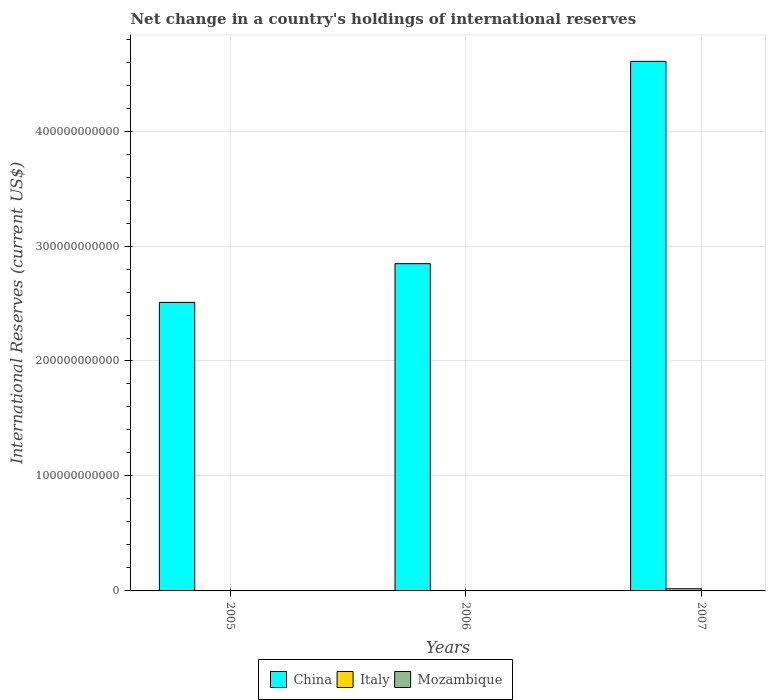Are the number of bars on each tick of the X-axis equal?
Ensure brevity in your answer.  No. How many bars are there on the 3rd tick from the left?
Provide a succinct answer. 3. How many bars are there on the 3rd tick from the right?
Offer a very short reply. 1. What is the label of the 2nd group of bars from the left?
Your answer should be very brief. 2006. In how many cases, is the number of bars for a given year not equal to the number of legend labels?
Offer a terse response. 2. Across all years, what is the maximum international reserves in Italy?
Provide a succinct answer. 1.89e+09. Across all years, what is the minimum international reserves in China?
Your response must be concise. 2.51e+11. In which year was the international reserves in Mozambique maximum?
Provide a short and direct response. 2007. What is the total international reserves in Italy in the graph?
Provide a short and direct response. 1.89e+09. What is the difference between the international reserves in China in 2005 and that in 2006?
Keep it short and to the point. -3.37e+1. What is the difference between the international reserves in Italy in 2007 and the international reserves in China in 2006?
Provide a succinct answer. -2.83e+11. What is the average international reserves in China per year?
Your answer should be very brief. 3.32e+11. In the year 2007, what is the difference between the international reserves in Italy and international reserves in Mozambique?
Your answer should be very brief. 1.76e+09. In how many years, is the international reserves in Italy greater than 60000000000 US$?
Make the answer very short. 0. What is the ratio of the international reserves in China in 2005 to that in 2007?
Provide a short and direct response. 0.54. What is the difference between the highest and the second highest international reserves in China?
Offer a very short reply. 1.76e+11. What is the difference between the highest and the lowest international reserves in Mozambique?
Make the answer very short. 1.37e+08. In how many years, is the international reserves in Mozambique greater than the average international reserves in Mozambique taken over all years?
Provide a short and direct response. 1. Is the sum of the international reserves in China in 2005 and 2006 greater than the maximum international reserves in Italy across all years?
Offer a terse response. Yes. How many bars are there?
Your answer should be compact. 5. What is the difference between two consecutive major ticks on the Y-axis?
Offer a very short reply. 1.00e+11. Does the graph contain any zero values?
Your response must be concise. Yes. How many legend labels are there?
Offer a very short reply. 3. How are the legend labels stacked?
Your answer should be very brief. Horizontal. What is the title of the graph?
Your answer should be compact. Net change in a country's holdings of international reserves. What is the label or title of the X-axis?
Ensure brevity in your answer.  Years. What is the label or title of the Y-axis?
Ensure brevity in your answer.  International Reserves (current US$). What is the International Reserves (current US$) in China in 2005?
Give a very brief answer. 2.51e+11. What is the International Reserves (current US$) in China in 2006?
Offer a very short reply. 2.85e+11. What is the International Reserves (current US$) of China in 2007?
Your answer should be compact. 4.61e+11. What is the International Reserves (current US$) of Italy in 2007?
Your answer should be very brief. 1.89e+09. What is the International Reserves (current US$) of Mozambique in 2007?
Ensure brevity in your answer.  1.37e+08. Across all years, what is the maximum International Reserves (current US$) of China?
Your answer should be compact. 4.61e+11. Across all years, what is the maximum International Reserves (current US$) in Italy?
Your answer should be very brief. 1.89e+09. Across all years, what is the maximum International Reserves (current US$) in Mozambique?
Offer a terse response. 1.37e+08. Across all years, what is the minimum International Reserves (current US$) in China?
Give a very brief answer. 2.51e+11. Across all years, what is the minimum International Reserves (current US$) in Mozambique?
Provide a succinct answer. 0. What is the total International Reserves (current US$) in China in the graph?
Ensure brevity in your answer.  9.96e+11. What is the total International Reserves (current US$) of Italy in the graph?
Provide a short and direct response. 1.89e+09. What is the total International Reserves (current US$) of Mozambique in the graph?
Your answer should be very brief. 1.37e+08. What is the difference between the International Reserves (current US$) of China in 2005 and that in 2006?
Provide a succinct answer. -3.37e+1. What is the difference between the International Reserves (current US$) in China in 2005 and that in 2007?
Ensure brevity in your answer.  -2.10e+11. What is the difference between the International Reserves (current US$) in China in 2006 and that in 2007?
Your answer should be very brief. -1.76e+11. What is the difference between the International Reserves (current US$) in China in 2005 and the International Reserves (current US$) in Italy in 2007?
Offer a very short reply. 2.49e+11. What is the difference between the International Reserves (current US$) of China in 2005 and the International Reserves (current US$) of Mozambique in 2007?
Keep it short and to the point. 2.51e+11. What is the difference between the International Reserves (current US$) in China in 2006 and the International Reserves (current US$) in Italy in 2007?
Ensure brevity in your answer.  2.83e+11. What is the difference between the International Reserves (current US$) of China in 2006 and the International Reserves (current US$) of Mozambique in 2007?
Offer a very short reply. 2.85e+11. What is the average International Reserves (current US$) in China per year?
Ensure brevity in your answer.  3.32e+11. What is the average International Reserves (current US$) of Italy per year?
Give a very brief answer. 6.31e+08. What is the average International Reserves (current US$) in Mozambique per year?
Keep it short and to the point. 4.57e+07. In the year 2007, what is the difference between the International Reserves (current US$) of China and International Reserves (current US$) of Italy?
Offer a very short reply. 4.59e+11. In the year 2007, what is the difference between the International Reserves (current US$) in China and International Reserves (current US$) in Mozambique?
Make the answer very short. 4.61e+11. In the year 2007, what is the difference between the International Reserves (current US$) of Italy and International Reserves (current US$) of Mozambique?
Ensure brevity in your answer.  1.76e+09. What is the ratio of the International Reserves (current US$) in China in 2005 to that in 2006?
Make the answer very short. 0.88. What is the ratio of the International Reserves (current US$) of China in 2005 to that in 2007?
Your answer should be compact. 0.54. What is the ratio of the International Reserves (current US$) in China in 2006 to that in 2007?
Provide a succinct answer. 0.62. What is the difference between the highest and the second highest International Reserves (current US$) in China?
Offer a very short reply. 1.76e+11. What is the difference between the highest and the lowest International Reserves (current US$) in China?
Your answer should be very brief. 2.10e+11. What is the difference between the highest and the lowest International Reserves (current US$) of Italy?
Offer a terse response. 1.89e+09. What is the difference between the highest and the lowest International Reserves (current US$) of Mozambique?
Your response must be concise. 1.37e+08. 